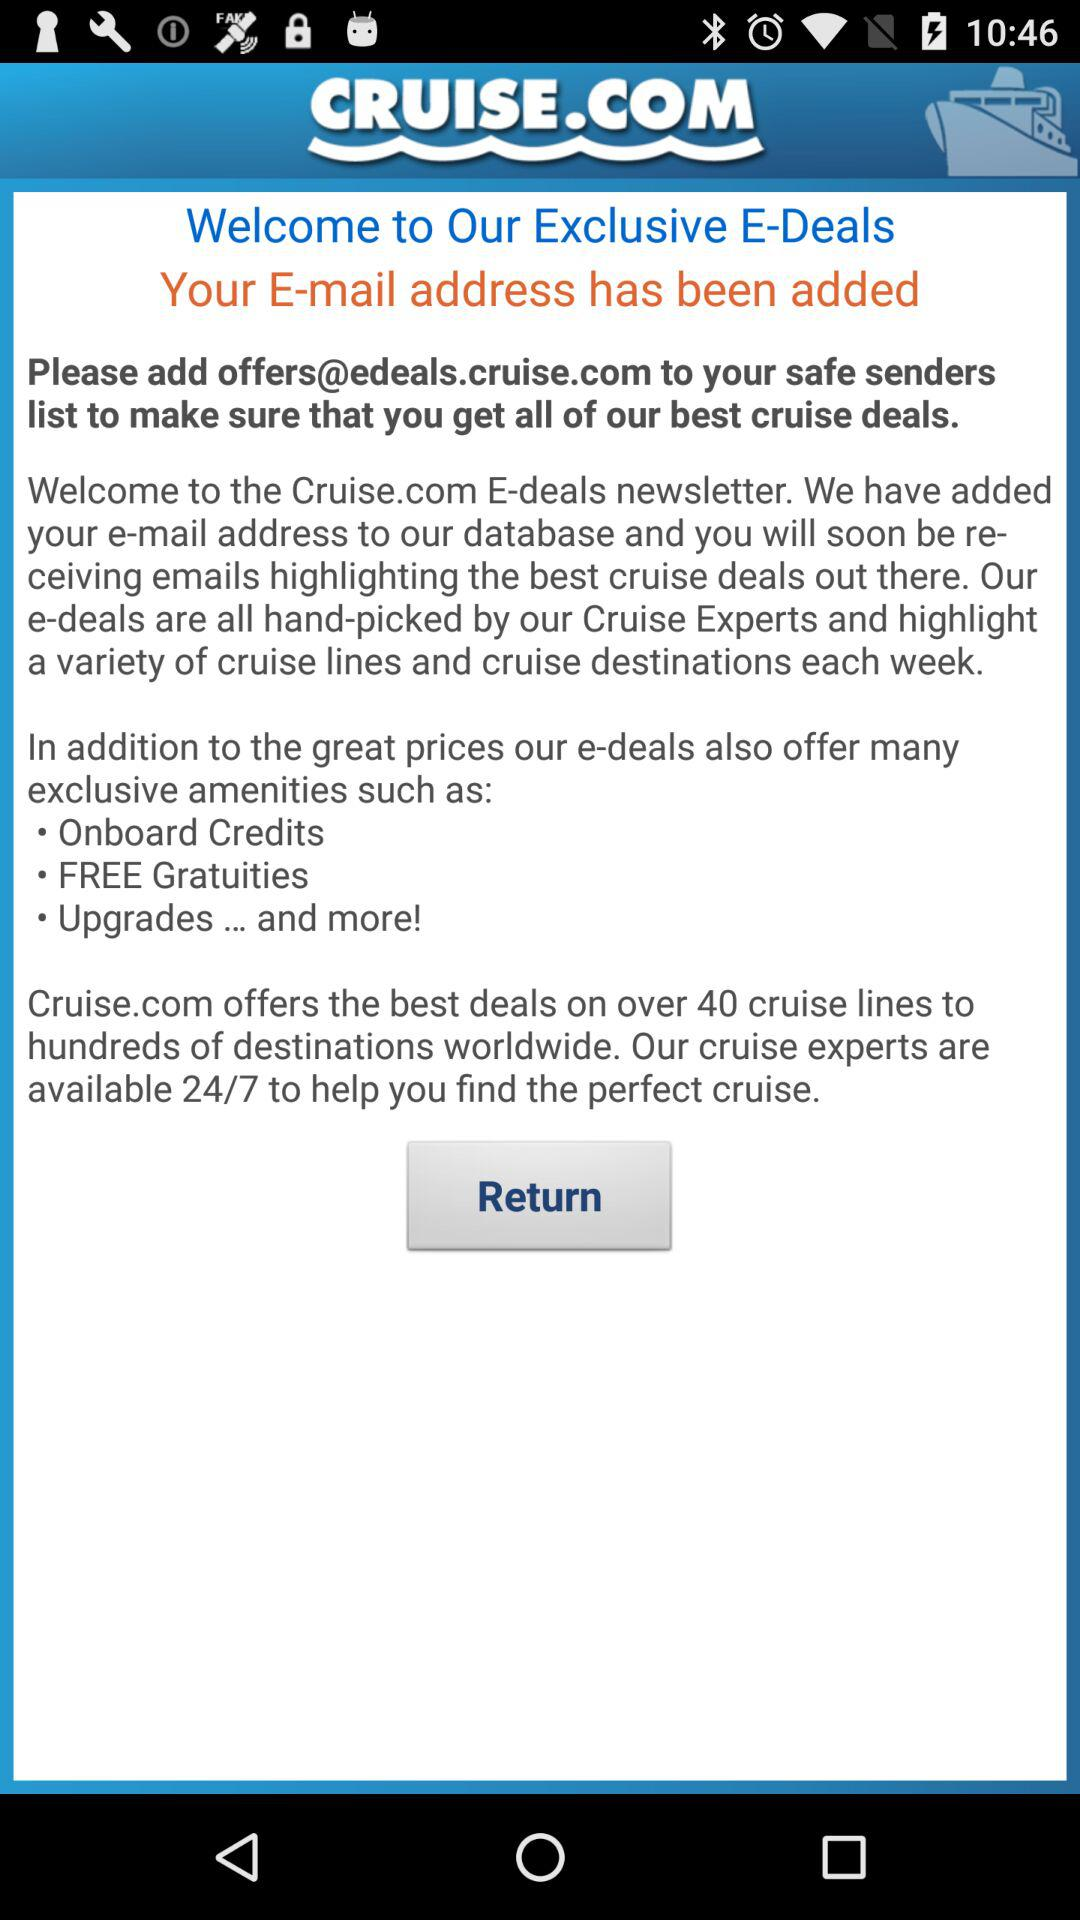What is the name of the application? The name of the application is "Cruise.com". 